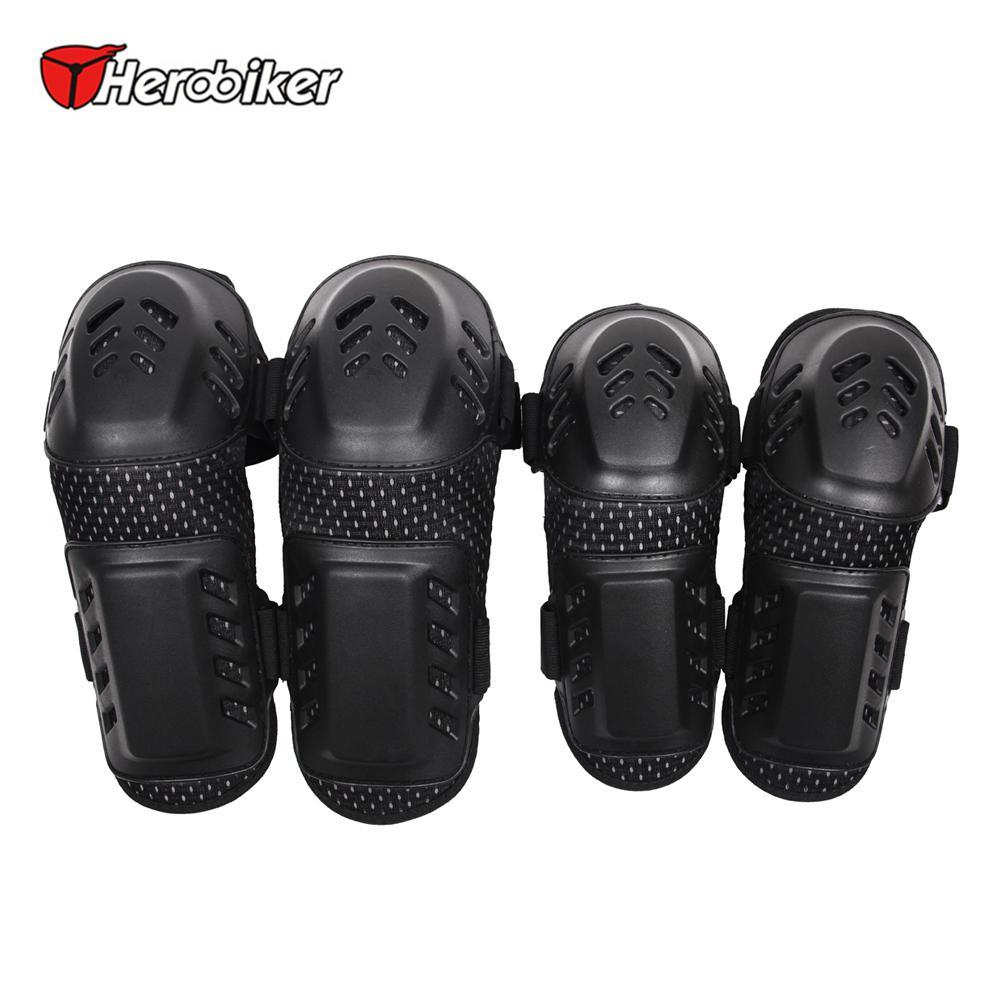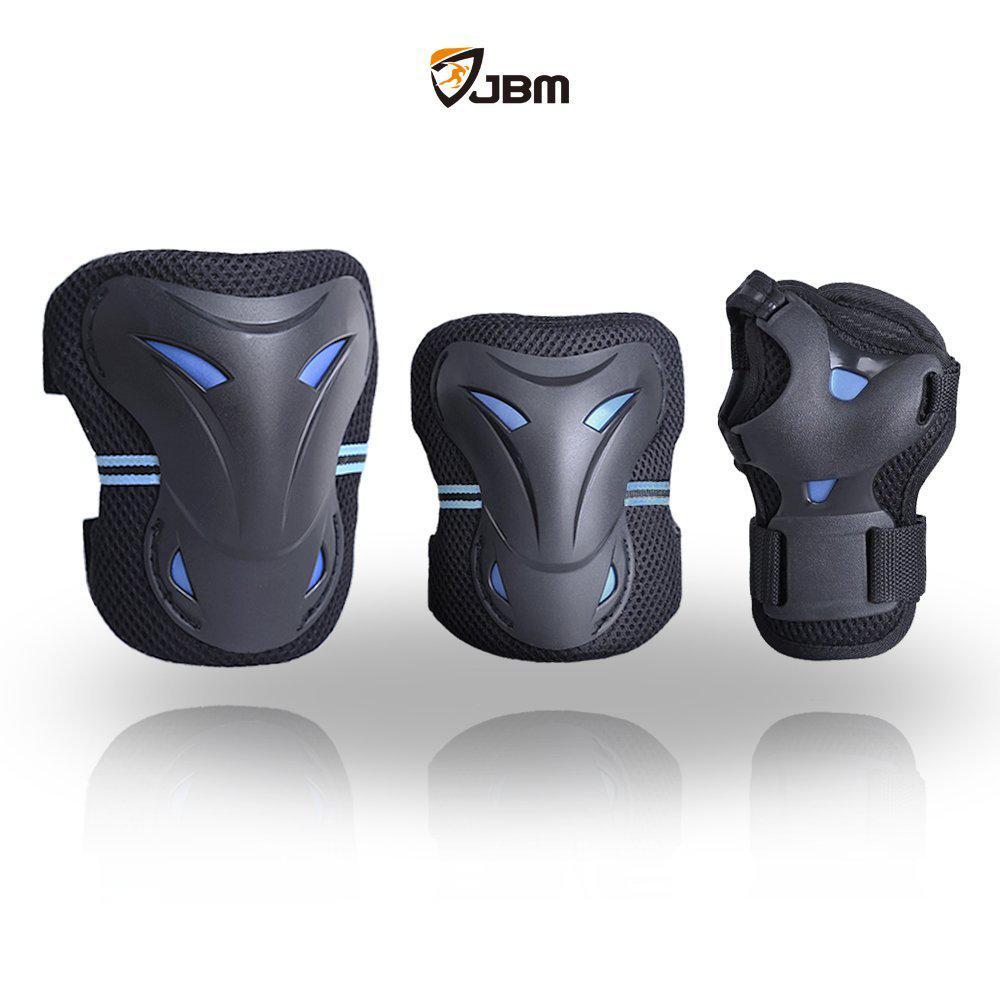The first image is the image on the left, the second image is the image on the right. Analyze the images presented: Is the assertion "All the pads are facing right." valid? Answer yes or no. No. The first image is the image on the left, the second image is the image on the right. Considering the images on both sides, is "there are 4 knee pads in each image pair" valid? Answer yes or no. No. 